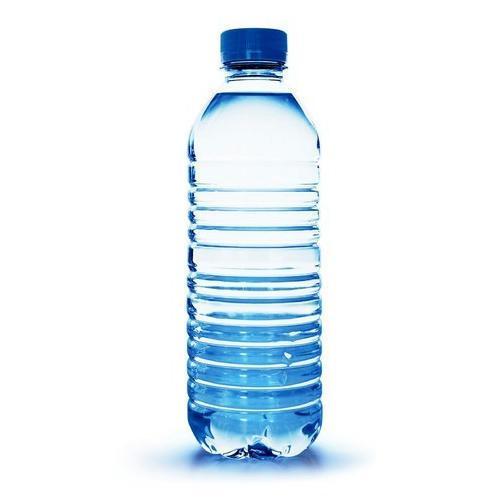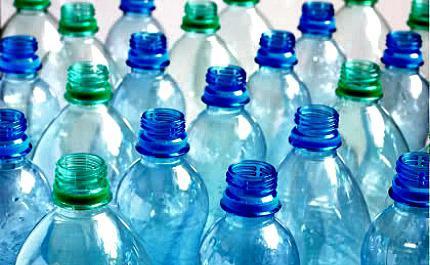The first image is the image on the left, the second image is the image on the right. Considering the images on both sides, is "One of the images is of a single water bottle with a blue cap." valid? Answer yes or no. Yes. The first image is the image on the left, the second image is the image on the right. Assess this claim about the two images: "In one image, a single drinking water bottle has a blue cap and no label.". Correct or not? Answer yes or no. Yes. 